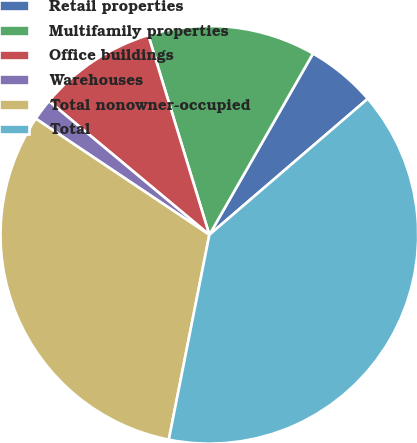Convert chart to OTSL. <chart><loc_0><loc_0><loc_500><loc_500><pie_chart><fcel>Retail properties<fcel>Multifamily properties<fcel>Office buildings<fcel>Warehouses<fcel>Total nonowner-occupied<fcel>Total<nl><fcel>5.44%<fcel>12.99%<fcel>9.22%<fcel>1.67%<fcel>31.27%<fcel>39.4%<nl></chart> 